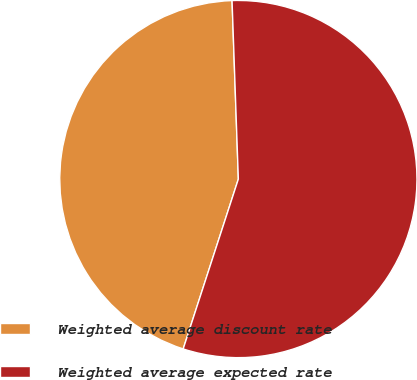Convert chart. <chart><loc_0><loc_0><loc_500><loc_500><pie_chart><fcel>Weighted average discount rate<fcel>Weighted average expected rate<nl><fcel>44.44%<fcel>55.56%<nl></chart> 